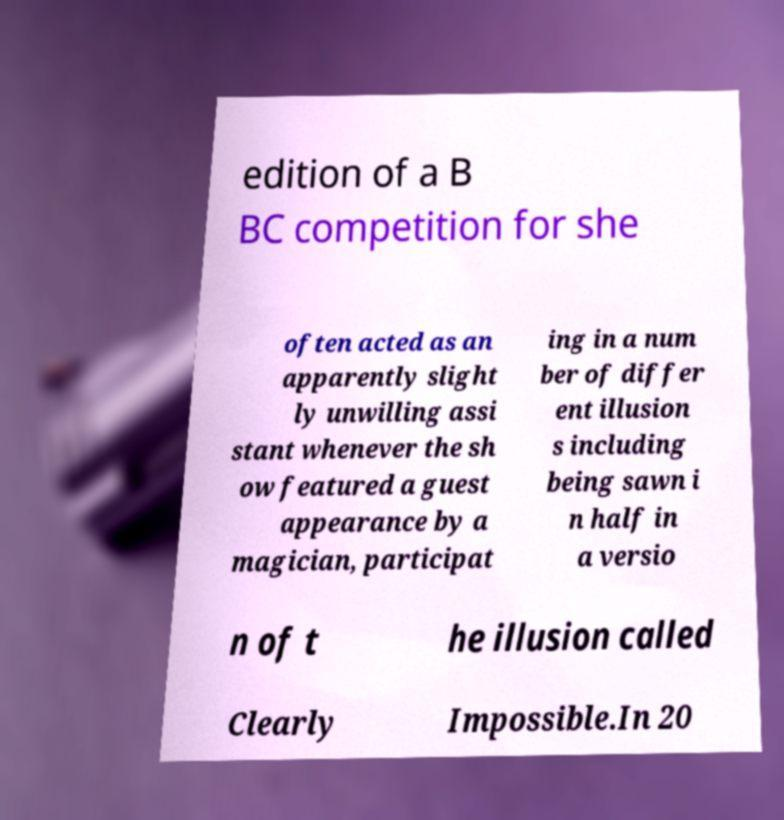There's text embedded in this image that I need extracted. Can you transcribe it verbatim? edition of a B BC competition for she often acted as an apparently slight ly unwilling assi stant whenever the sh ow featured a guest appearance by a magician, participat ing in a num ber of differ ent illusion s including being sawn i n half in a versio n of t he illusion called Clearly Impossible.In 20 